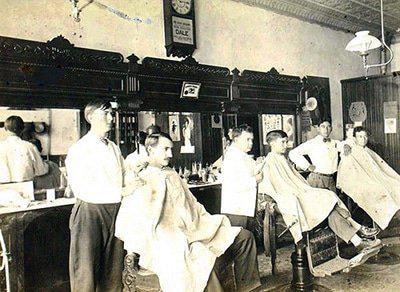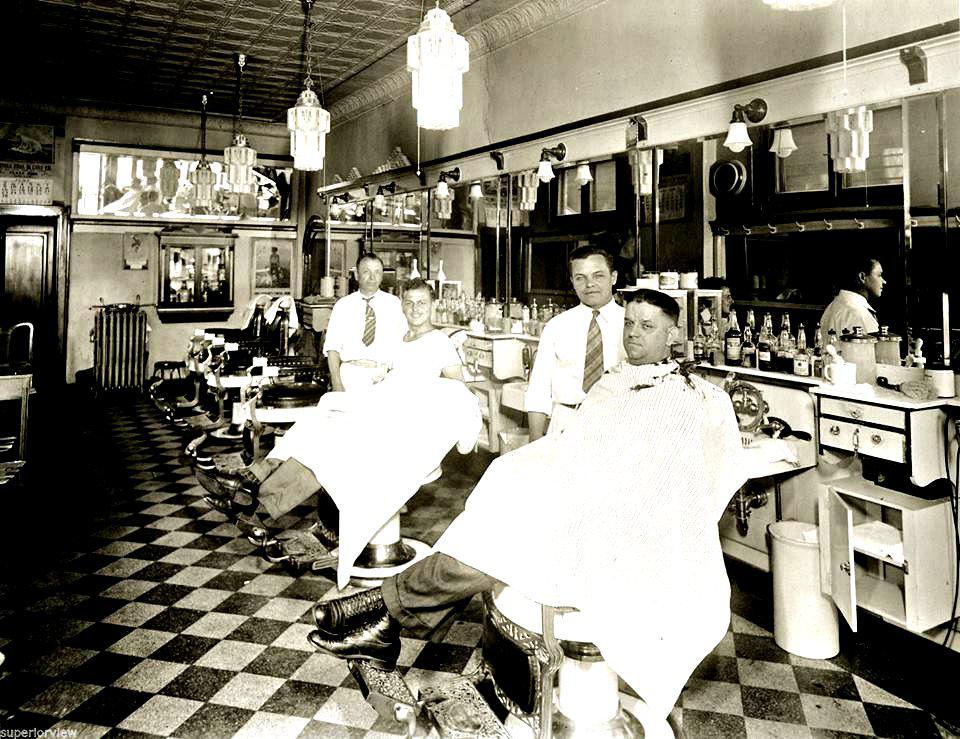The first image is the image on the left, the second image is the image on the right. Examine the images to the left and right. Is the description "Five barbers are working with customers seated in chairs." accurate? Answer yes or no. Yes. The first image is the image on the left, the second image is the image on the right. For the images shown, is this caption "There are exactly two men sitting in barbers chairs in the image on the right." true? Answer yes or no. Yes. 